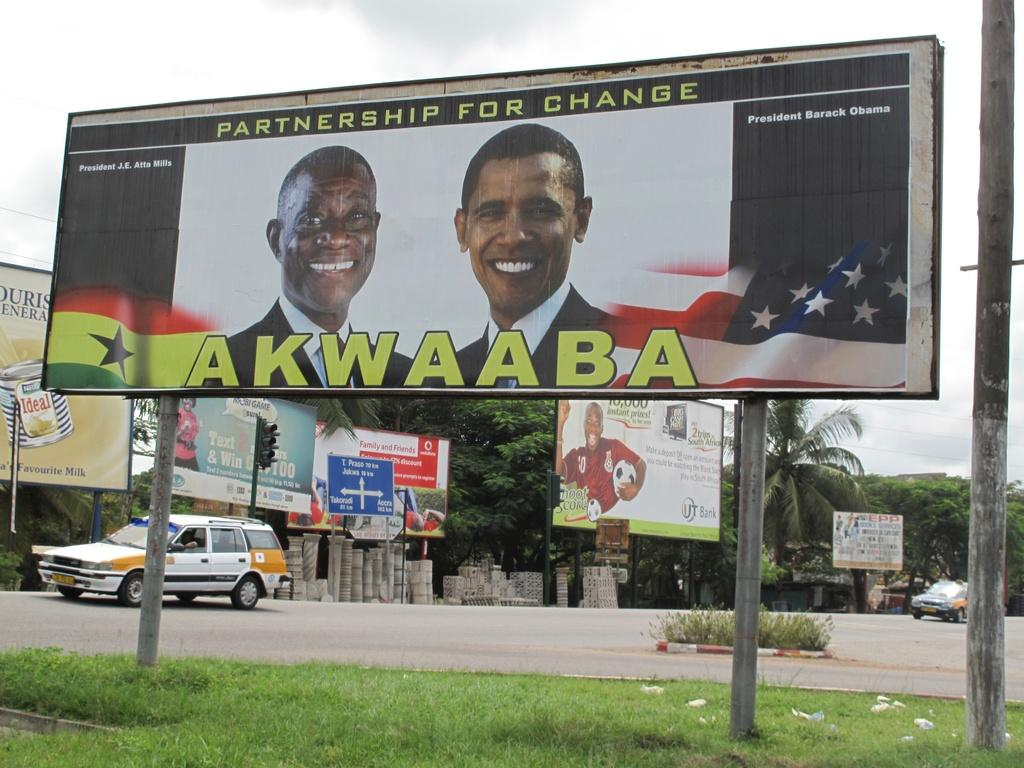Provide a one-sentence caption for the provided image. A billboard with the words partnership for change appears above two politicians. 